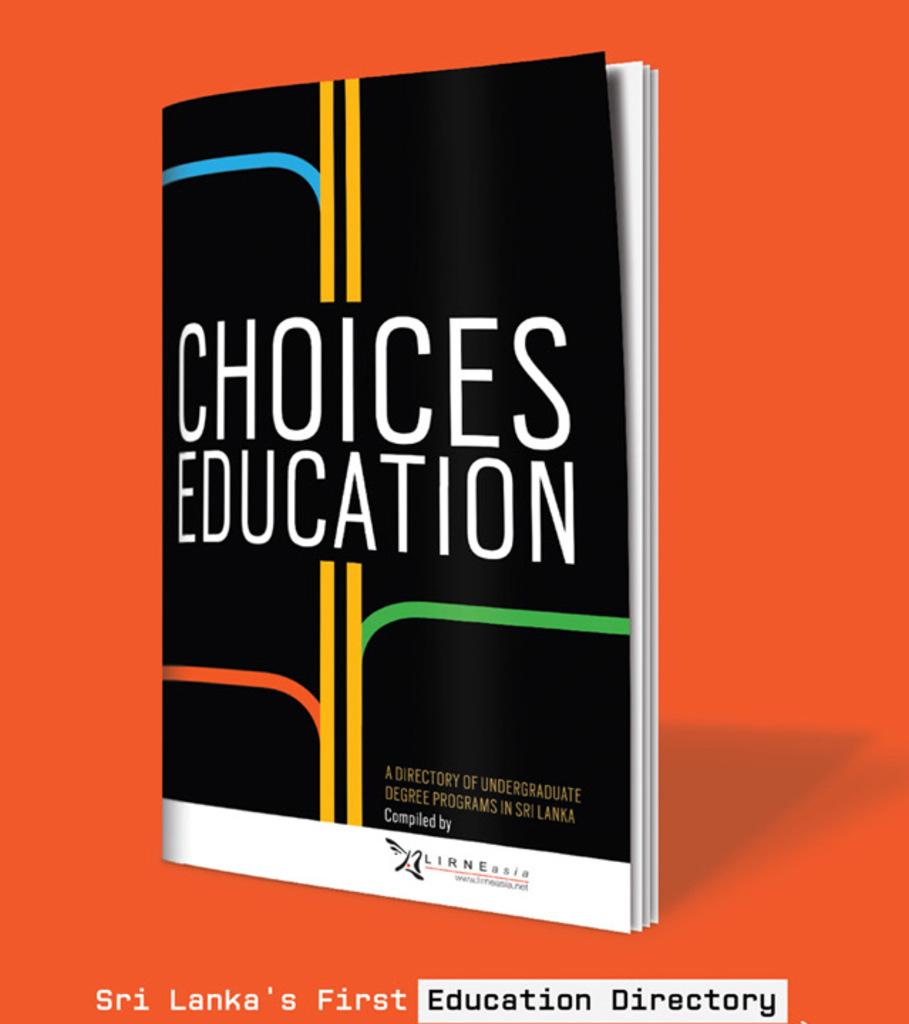What country is this for?
Your answer should be compact. Sri lanka. Is this a directory of undergrad programs in sri lanka?
Provide a short and direct response. Yes. 